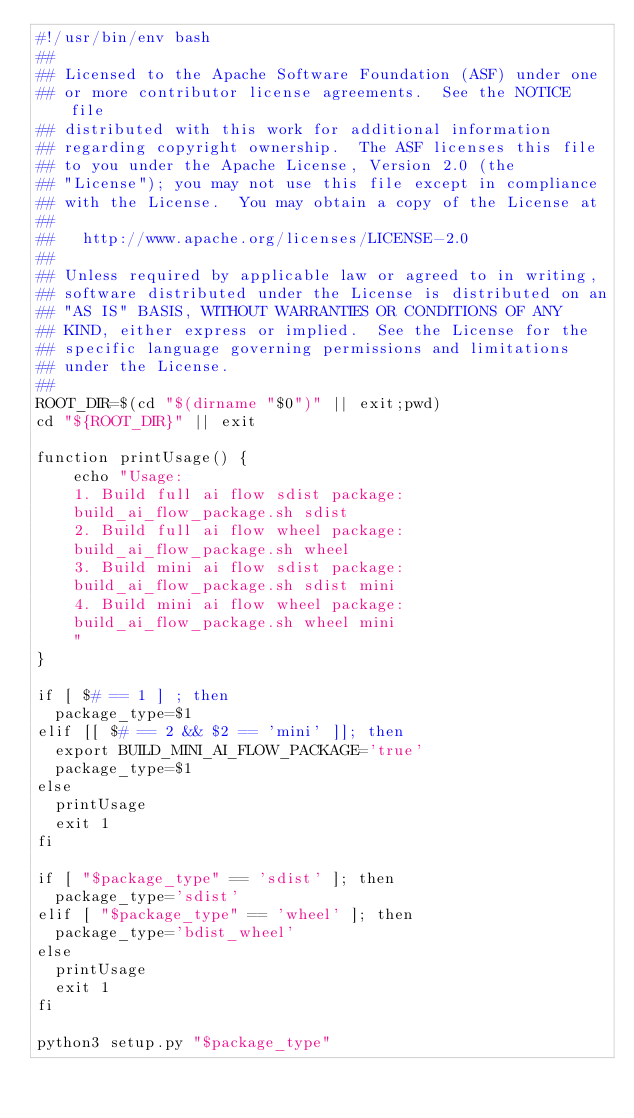Convert code to text. <code><loc_0><loc_0><loc_500><loc_500><_Bash_>#!/usr/bin/env bash
##
## Licensed to the Apache Software Foundation (ASF) under one
## or more contributor license agreements.  See the NOTICE file
## distributed with this work for additional information
## regarding copyright ownership.  The ASF licenses this file
## to you under the Apache License, Version 2.0 (the
## "License"); you may not use this file except in compliance
## with the License.  You may obtain a copy of the License at
##
##   http://www.apache.org/licenses/LICENSE-2.0
##
## Unless required by applicable law or agreed to in writing,
## software distributed under the License is distributed on an
## "AS IS" BASIS, WITHOUT WARRANTIES OR CONDITIONS OF ANY
## KIND, either express or implied.  See the License for the
## specific language governing permissions and limitations
## under the License.
##
ROOT_DIR=$(cd "$(dirname "$0")" || exit;pwd)
cd "${ROOT_DIR}" || exit

function printUsage() {
    echo "Usage:
    1. Build full ai flow sdist package:
    build_ai_flow_package.sh sdist
    2. Build full ai flow wheel package:
    build_ai_flow_package.sh wheel
    3. Build mini ai flow sdist package:
    build_ai_flow_package.sh sdist mini
    4. Build mini ai flow wheel package:
    build_ai_flow_package.sh wheel mini
    "
}

if [ $# == 1 ] ; then
  package_type=$1
elif [[ $# == 2 && $2 == 'mini' ]]; then
  export BUILD_MINI_AI_FLOW_PACKAGE='true'
  package_type=$1
else
  printUsage
  exit 1
fi

if [ "$package_type" == 'sdist' ]; then
  package_type='sdist'
elif [ "$package_type" == 'wheel' ]; then
  package_type='bdist_wheel'
else
  printUsage
  exit 1
fi

python3 setup.py "$package_type"
</code> 